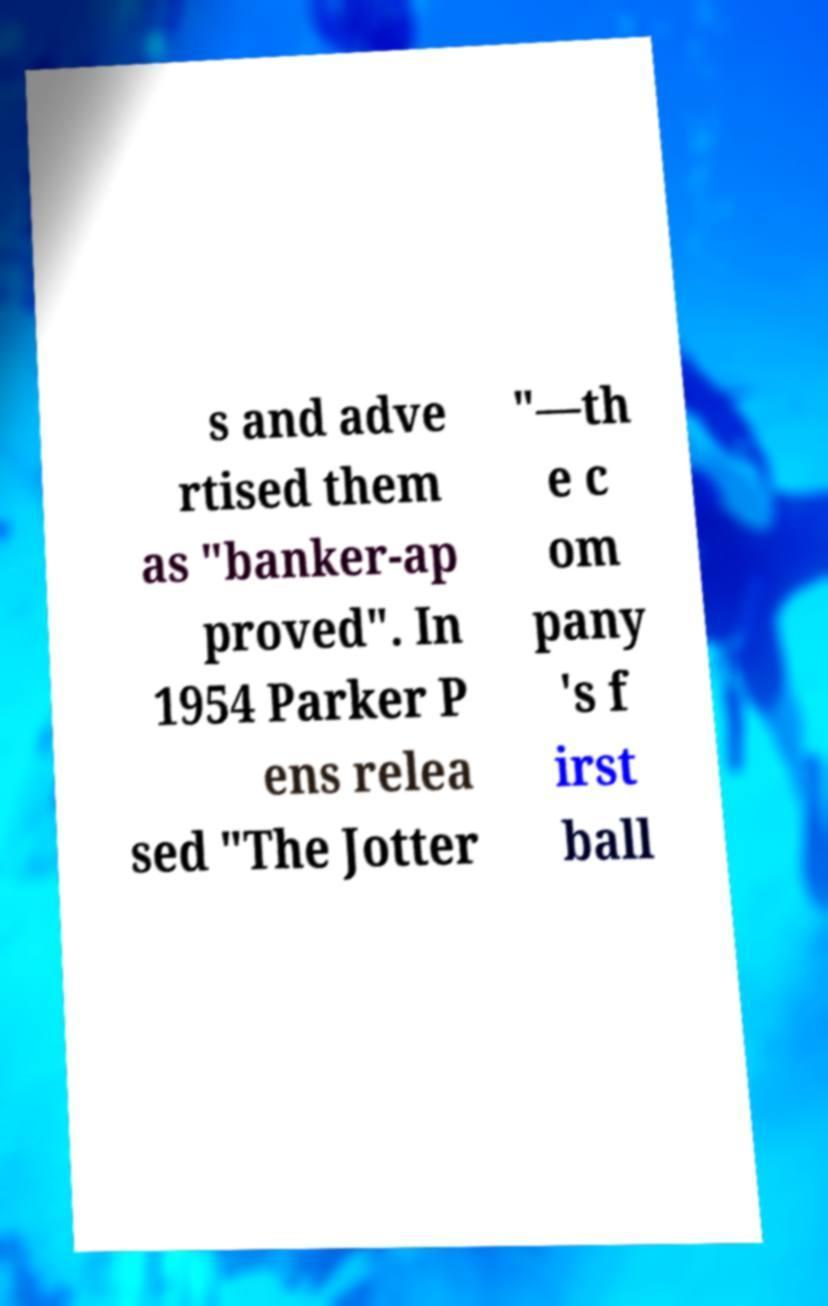Please read and relay the text visible in this image. What does it say? s and adve rtised them as "banker-ap proved". In 1954 Parker P ens relea sed "The Jotter "—th e c om pany 's f irst ball 